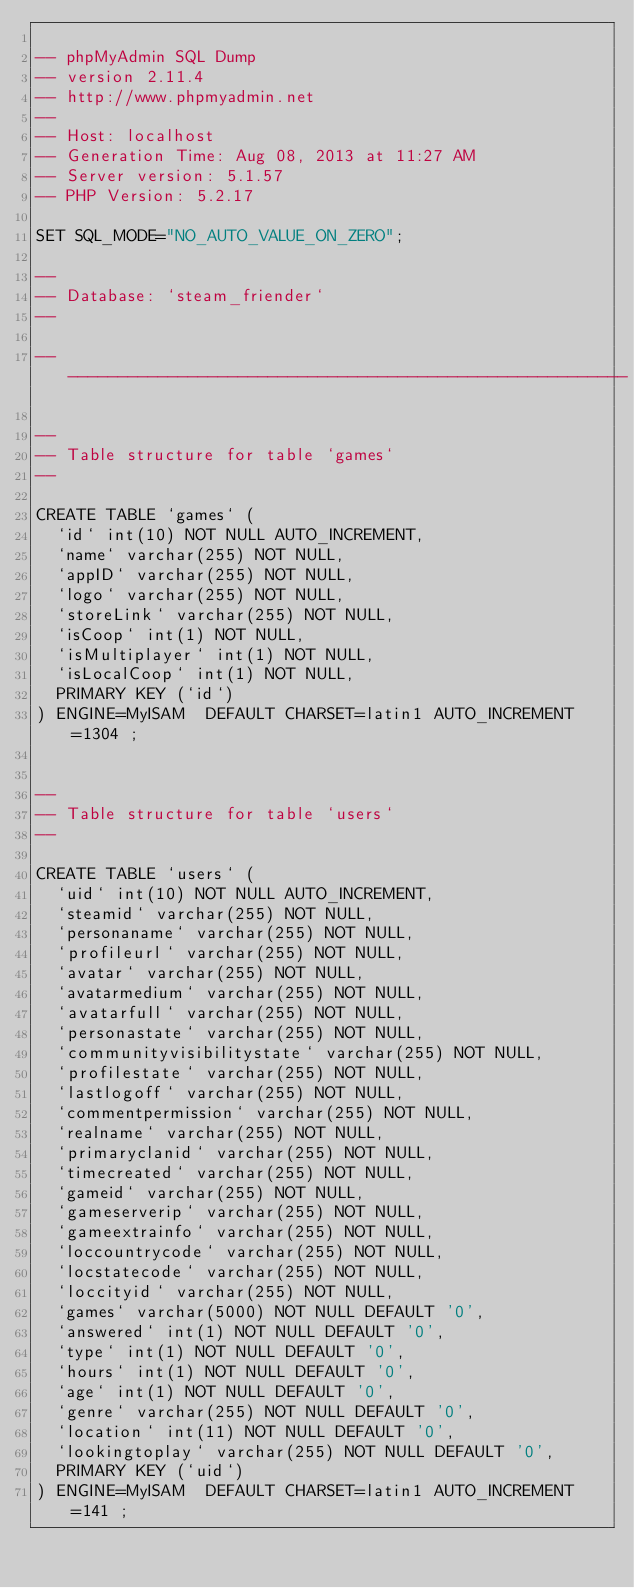Convert code to text. <code><loc_0><loc_0><loc_500><loc_500><_SQL_>
-- phpMyAdmin SQL Dump
-- version 2.11.4
-- http://www.phpmyadmin.net
--
-- Host: localhost
-- Generation Time: Aug 08, 2013 at 11:27 AM
-- Server version: 5.1.57
-- PHP Version: 5.2.17

SET SQL_MODE="NO_AUTO_VALUE_ON_ZERO";

--
-- Database: `steam_friender`
--

-- --------------------------------------------------------

--
-- Table structure for table `games`
--

CREATE TABLE `games` (
  `id` int(10) NOT NULL AUTO_INCREMENT,
  `name` varchar(255) NOT NULL,
  `appID` varchar(255) NOT NULL,
  `logo` varchar(255) NOT NULL,
  `storeLink` varchar(255) NOT NULL,
  `isCoop` int(1) NOT NULL,
  `isMultiplayer` int(1) NOT NULL,
  `isLocalCoop` int(1) NOT NULL,
  PRIMARY KEY (`id`)
) ENGINE=MyISAM  DEFAULT CHARSET=latin1 AUTO_INCREMENT=1304 ;


--
-- Table structure for table `users`
--

CREATE TABLE `users` (
  `uid` int(10) NOT NULL AUTO_INCREMENT,
  `steamid` varchar(255) NOT NULL,
  `personaname` varchar(255) NOT NULL,
  `profileurl` varchar(255) NOT NULL,
  `avatar` varchar(255) NOT NULL,
  `avatarmedium` varchar(255) NOT NULL,
  `avatarfull` varchar(255) NOT NULL,
  `personastate` varchar(255) NOT NULL,
  `communityvisibilitystate` varchar(255) NOT NULL,
  `profilestate` varchar(255) NOT NULL,
  `lastlogoff` varchar(255) NOT NULL,
  `commentpermission` varchar(255) NOT NULL,
  `realname` varchar(255) NOT NULL,
  `primaryclanid` varchar(255) NOT NULL,
  `timecreated` varchar(255) NOT NULL,
  `gameid` varchar(255) NOT NULL,
  `gameserverip` varchar(255) NOT NULL,
  `gameextrainfo` varchar(255) NOT NULL,
  `loccountrycode` varchar(255) NOT NULL,
  `locstatecode` varchar(255) NOT NULL,
  `loccityid` varchar(255) NOT NULL,
  `games` varchar(5000) NOT NULL DEFAULT '0',
  `answered` int(1) NOT NULL DEFAULT '0',
  `type` int(1) NOT NULL DEFAULT '0',
  `hours` int(1) NOT NULL DEFAULT '0',
  `age` int(1) NOT NULL DEFAULT '0',
  `genre` varchar(255) NOT NULL DEFAULT '0',
  `location` int(11) NOT NULL DEFAULT '0',
  `lookingtoplay` varchar(255) NOT NULL DEFAULT '0',
  PRIMARY KEY (`uid`)
) ENGINE=MyISAM  DEFAULT CHARSET=latin1 AUTO_INCREMENT=141 ;</code> 